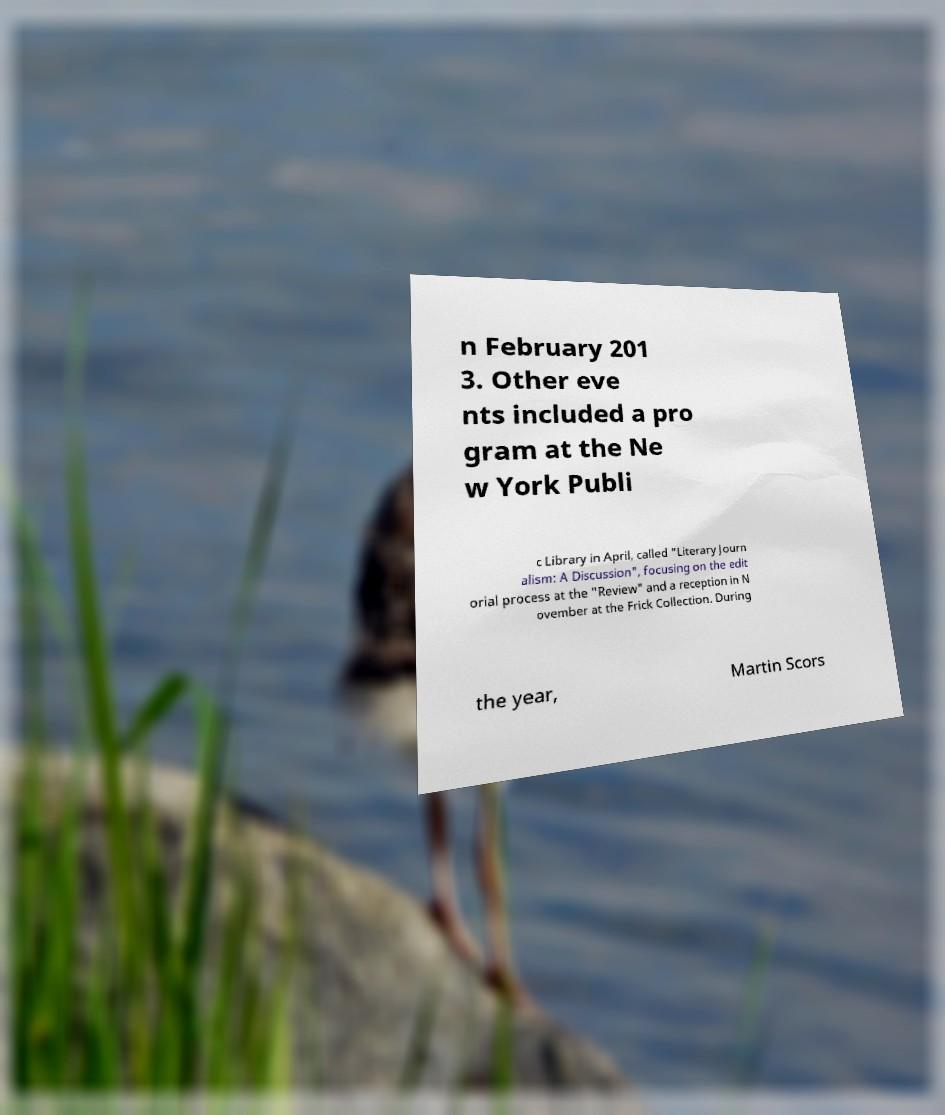Could you extract and type out the text from this image? n February 201 3. Other eve nts included a pro gram at the Ne w York Publi c Library in April, called "Literary Journ alism: A Discussion", focusing on the edit orial process at the "Review" and a reception in N ovember at the Frick Collection. During the year, Martin Scors 